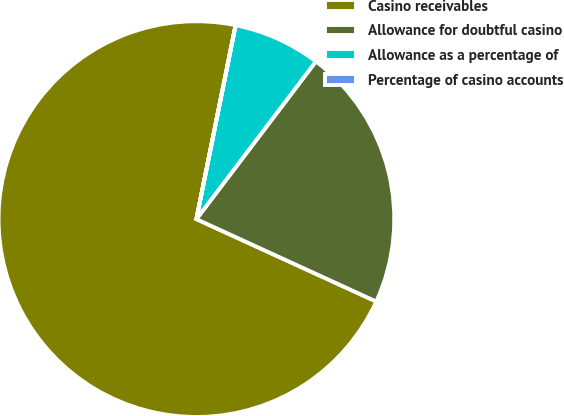<chart> <loc_0><loc_0><loc_500><loc_500><pie_chart><fcel>Casino receivables<fcel>Allowance for doubtful casino<fcel>Allowance as a percentage of<fcel>Percentage of casino accounts<nl><fcel>71.34%<fcel>21.52%<fcel>7.14%<fcel>0.01%<nl></chart> 